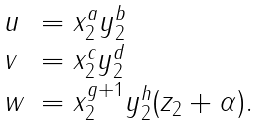Convert formula to latex. <formula><loc_0><loc_0><loc_500><loc_500>\begin{array} { l l } u & = x _ { 2 } ^ { a } y _ { 2 } ^ { b } \\ v & = x _ { 2 } ^ { c } y _ { 2 } ^ { d } \\ w & = x _ { 2 } ^ { g + 1 } y _ { 2 } ^ { h } ( z _ { 2 } + \alpha ) . \end{array}</formula> 